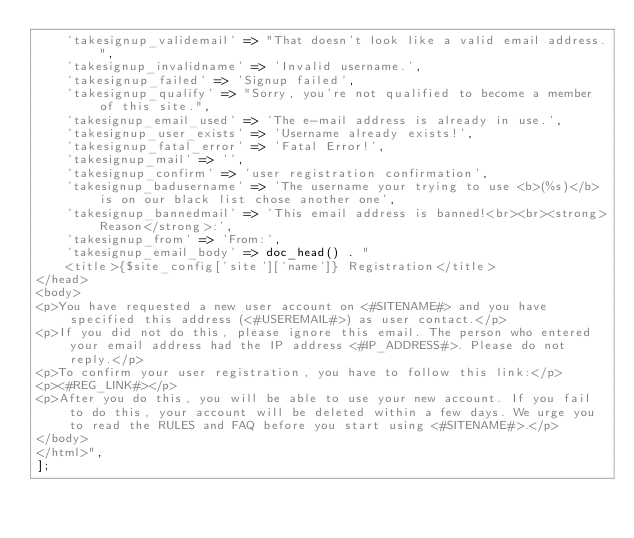<code> <loc_0><loc_0><loc_500><loc_500><_PHP_>    'takesignup_validemail' => "That doesn't look like a valid email address.",
    'takesignup_invalidname' => 'Invalid username.',
    'takesignup_failed' => 'Signup failed',
    'takesignup_qualify' => "Sorry, you're not qualified to become a member of this site.",
    'takesignup_email_used' => 'The e-mail address is already in use.',
    'takesignup_user_exists' => 'Username already exists!',
    'takesignup_fatal_error' => 'Fatal Error!',
    'takesignup_mail' => '',
    'takesignup_confirm' => 'user registration confirmation',
    'takesignup_badusername' => 'The username your trying to use <b>(%s)</b> is on our black list chose another one',
    'takesignup_bannedmail' => 'This email address is banned!<br><br><strong>Reason</strong>:',
    'takesignup_from' => 'From:',
    'takesignup_email_body' => doc_head() . "
    <title>{$site_config['site']['name']} Registration</title>
</head>
<body>
<p>You have requested a new user account on <#SITENAME#> and you have specified this address (<#USEREMAIL#>) as user contact.</p>
<p>If you did not do this, please ignore this email. The person who entered your email address had the IP address <#IP_ADDRESS#>. Please do not reply.</p>
<p>To confirm your user registration, you have to follow this link:</p>
<p><#REG_LINK#></p>
<p>After you do this, you will be able to use your new account. If you fail to do this, your account will be deleted within a few days. We urge you to read the RULES and FAQ before you start using <#SITENAME#>.</p>
</body>
</html>",
];
</code> 